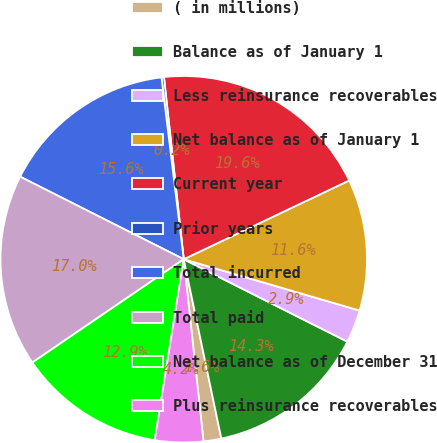<chart> <loc_0><loc_0><loc_500><loc_500><pie_chart><fcel>( in millions)<fcel>Balance as of January 1<fcel>Less reinsurance recoverables<fcel>Net balance as of January 1<fcel>Current year<fcel>Prior years<fcel>Total incurred<fcel>Total paid<fcel>Net balance as of December 31<fcel>Plus reinsurance recoverables<nl><fcel>1.57%<fcel>14.28%<fcel>2.91%<fcel>11.59%<fcel>19.65%<fcel>0.22%<fcel>15.62%<fcel>16.97%<fcel>12.94%<fcel>4.25%<nl></chart> 